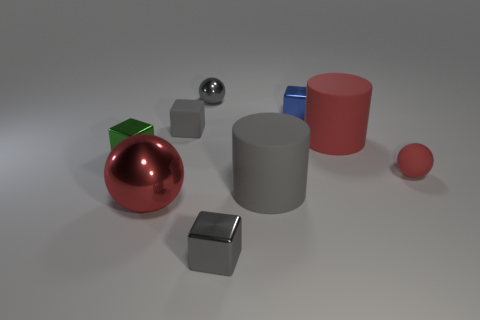Subtract 1 blocks. How many blocks are left? 3 Add 1 small cyan matte blocks. How many objects exist? 10 Subtract all blocks. How many objects are left? 5 Subtract all rubber balls. Subtract all big metal spheres. How many objects are left? 7 Add 2 gray cylinders. How many gray cylinders are left? 3 Add 7 tiny green metallic objects. How many tiny green metallic objects exist? 8 Subtract 0 purple balls. How many objects are left? 9 